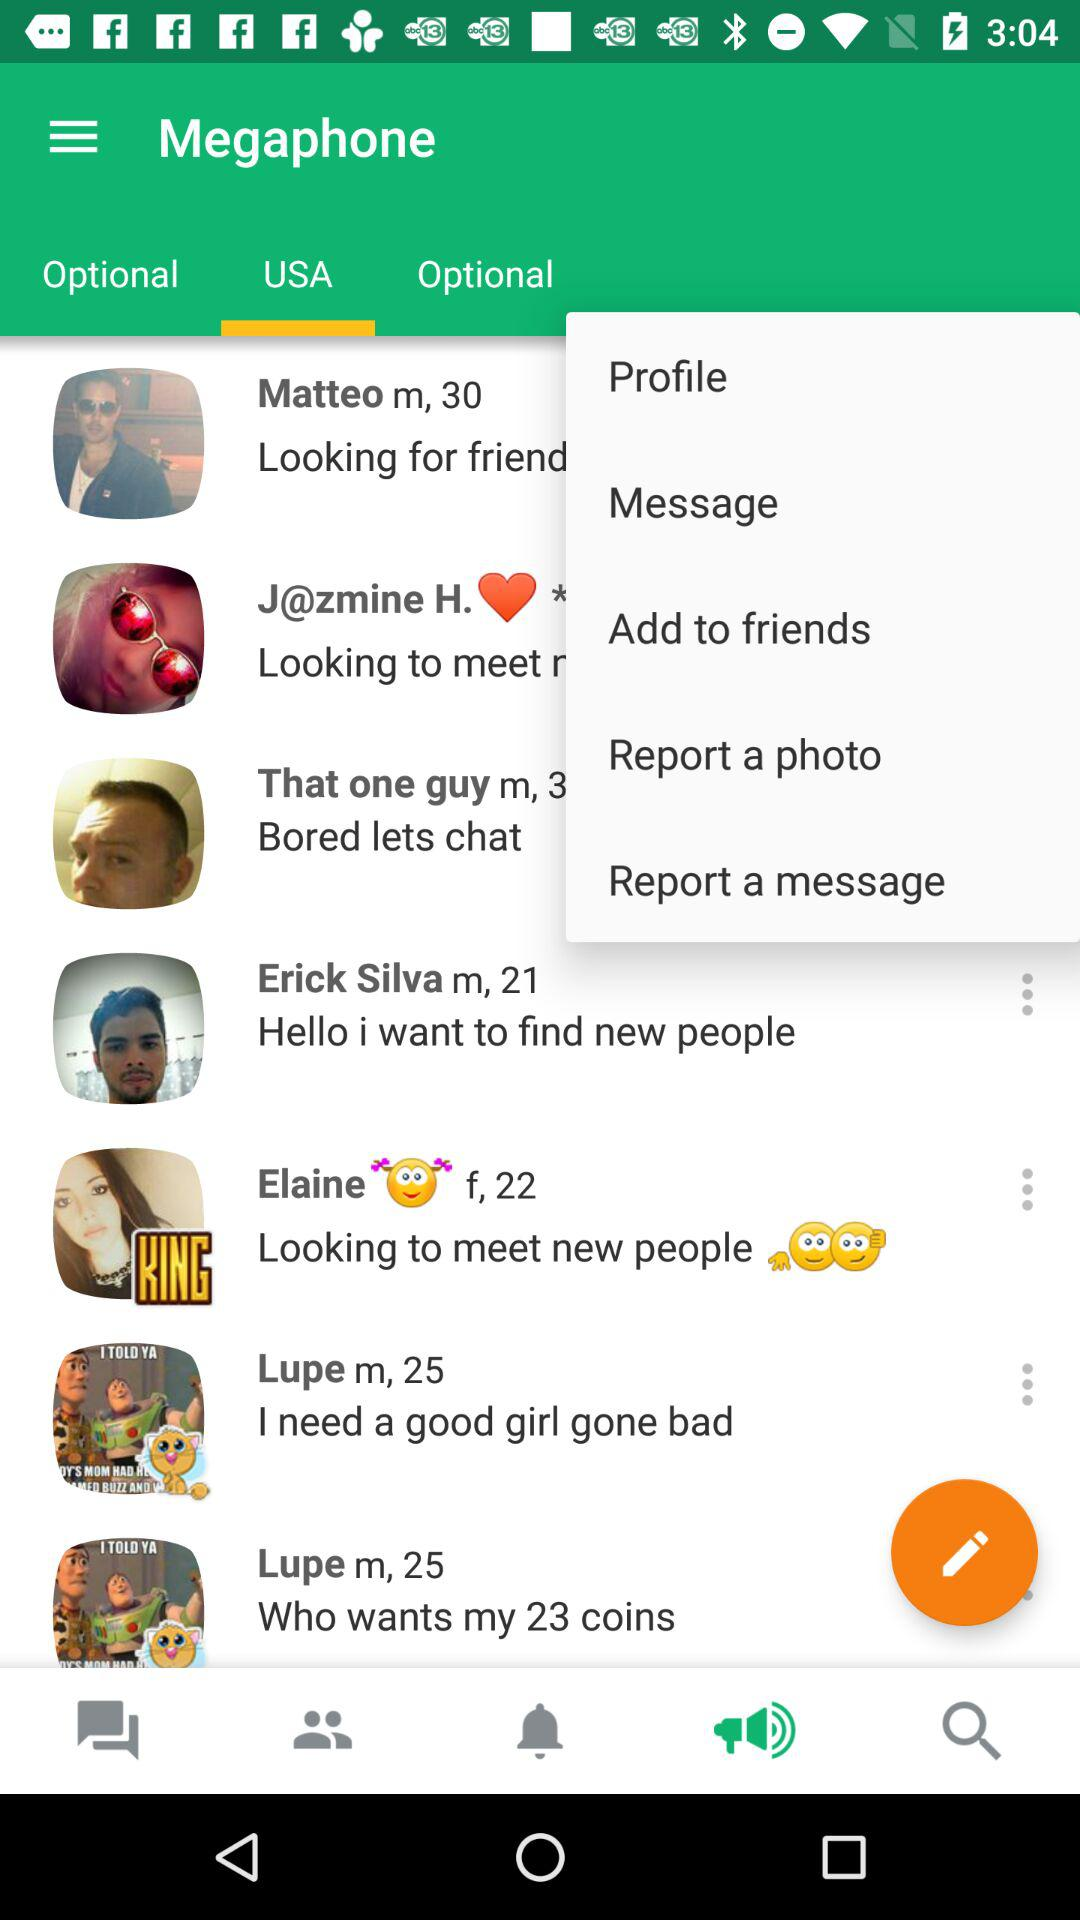What is the age of Matteo? Matteo is 30 years old. 